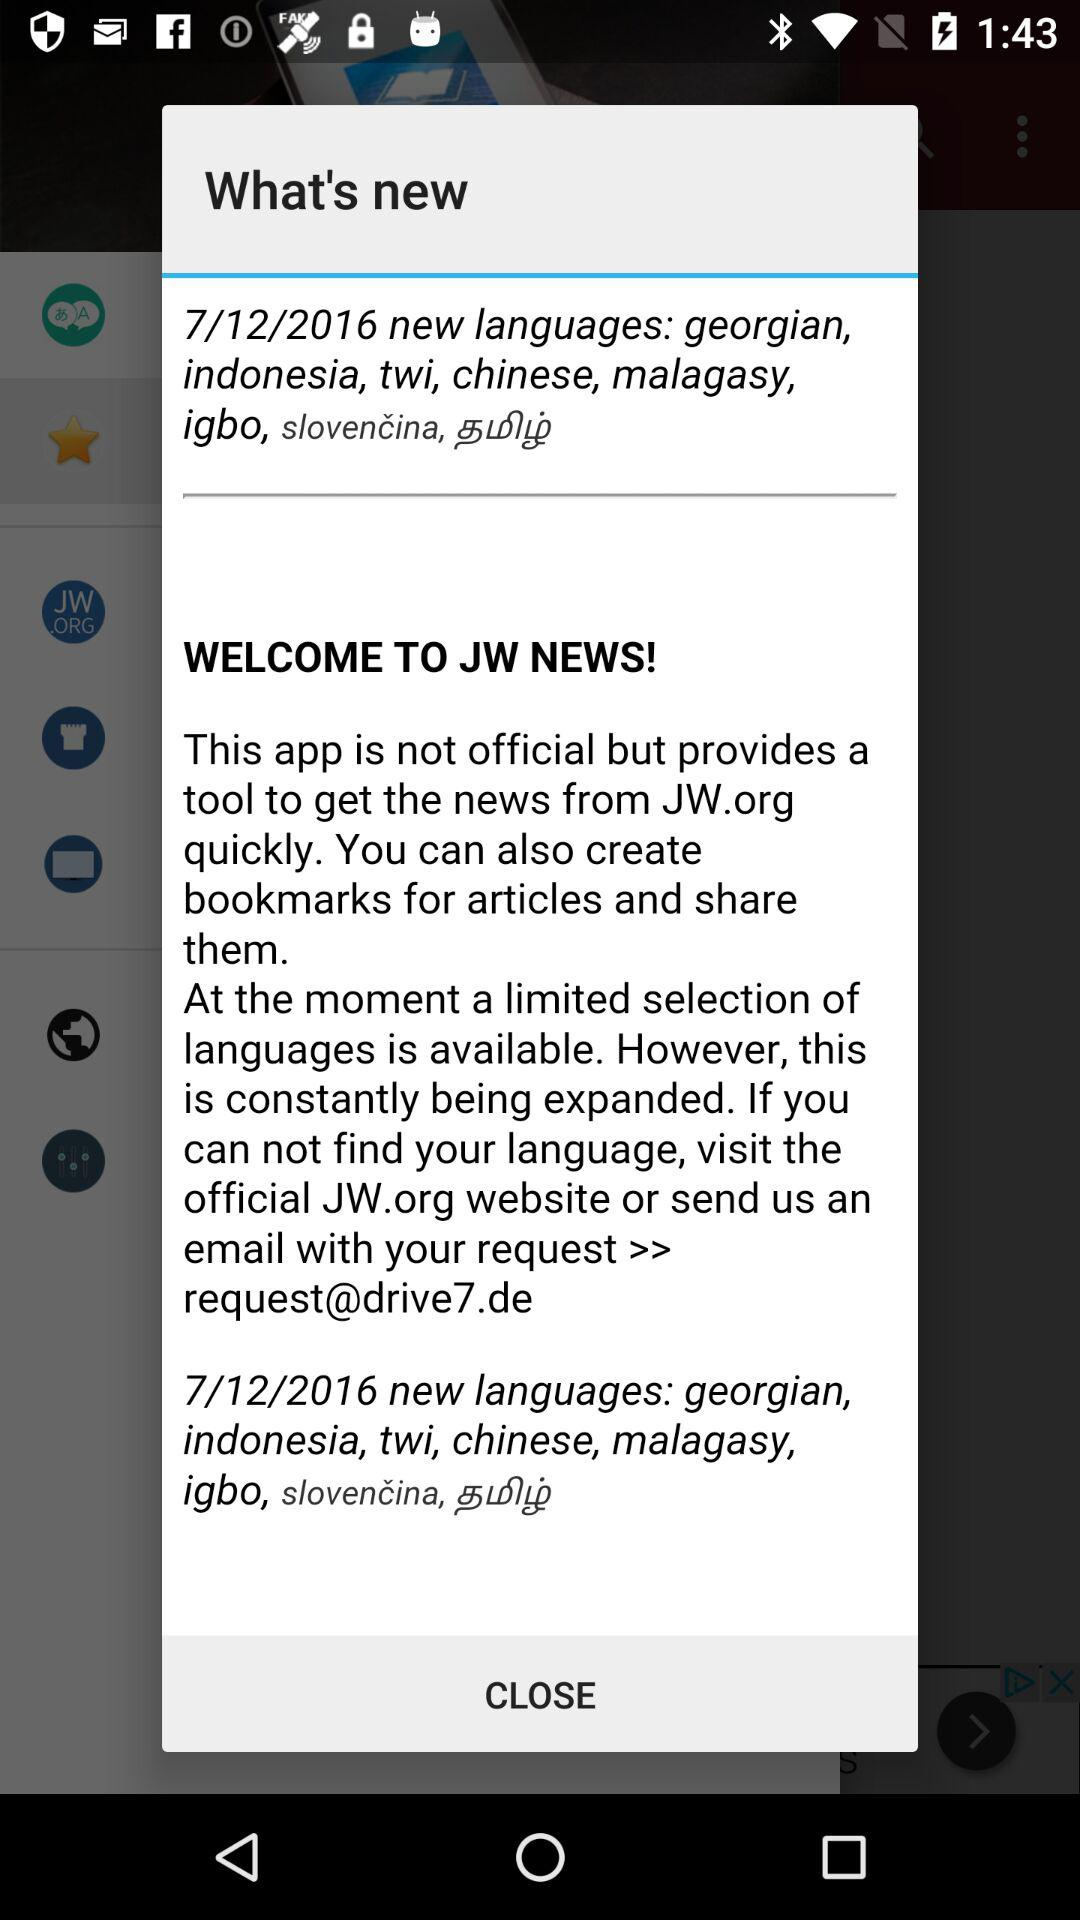What is the email address? The email address is request@drive7.de. 